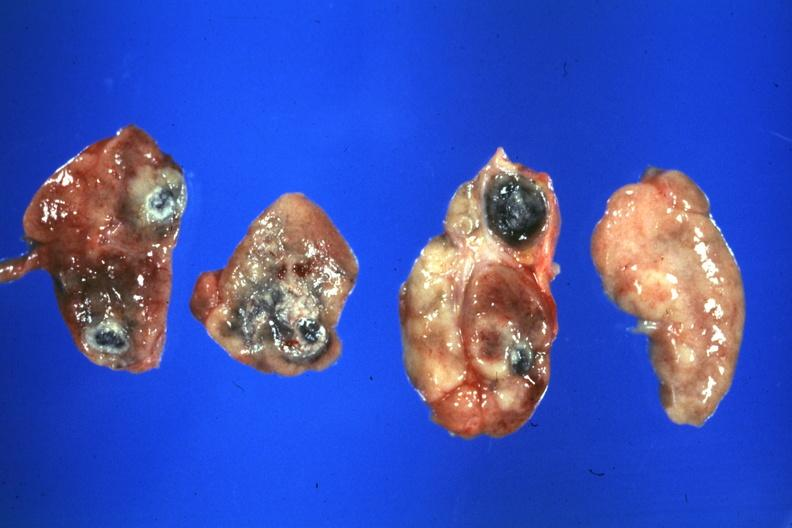s lymph node present?
Answer the question using a single word or phrase. Yes 